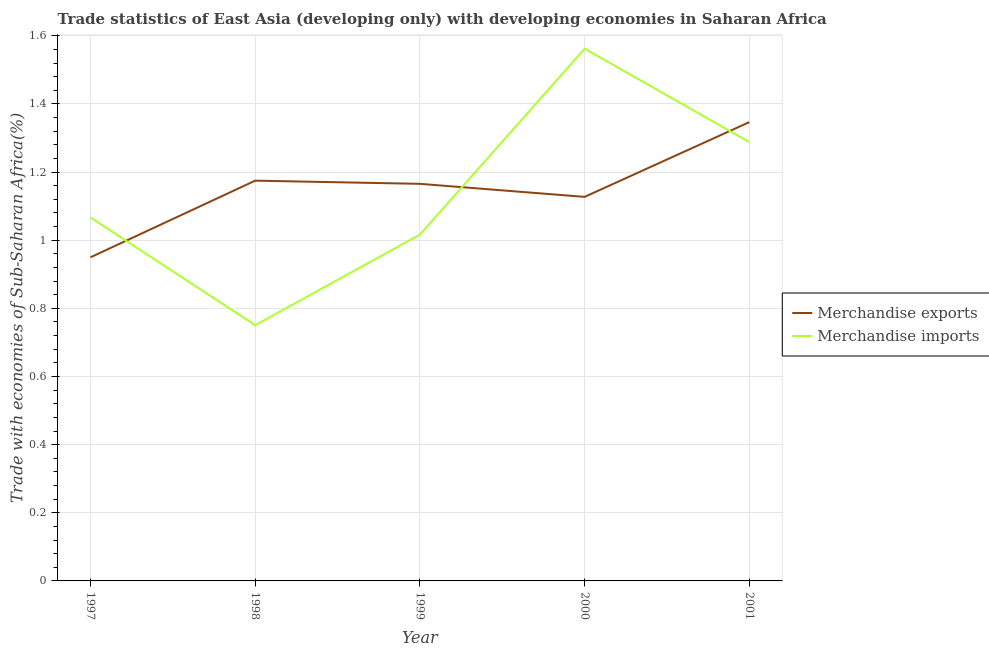How many different coloured lines are there?
Make the answer very short. 2. What is the merchandise exports in 1997?
Your response must be concise. 0.95. Across all years, what is the maximum merchandise imports?
Offer a terse response. 1.56. Across all years, what is the minimum merchandise imports?
Give a very brief answer. 0.75. In which year was the merchandise imports maximum?
Provide a short and direct response. 2000. In which year was the merchandise imports minimum?
Provide a short and direct response. 1998. What is the total merchandise imports in the graph?
Ensure brevity in your answer.  5.68. What is the difference between the merchandise exports in 1997 and that in 1998?
Provide a succinct answer. -0.22. What is the difference between the merchandise imports in 1999 and the merchandise exports in 2000?
Your answer should be very brief. -0.11. What is the average merchandise imports per year?
Ensure brevity in your answer.  1.14. In the year 2000, what is the difference between the merchandise exports and merchandise imports?
Give a very brief answer. -0.43. What is the ratio of the merchandise exports in 1997 to that in 1999?
Make the answer very short. 0.81. Is the merchandise imports in 1998 less than that in 2001?
Provide a short and direct response. Yes. Is the difference between the merchandise imports in 1997 and 2000 greater than the difference between the merchandise exports in 1997 and 2000?
Your answer should be very brief. No. What is the difference between the highest and the second highest merchandise imports?
Keep it short and to the point. 0.27. What is the difference between the highest and the lowest merchandise imports?
Your answer should be compact. 0.81. Is the sum of the merchandise exports in 1997 and 2001 greater than the maximum merchandise imports across all years?
Your answer should be very brief. Yes. Does the merchandise imports monotonically increase over the years?
Offer a terse response. No. Is the merchandise imports strictly greater than the merchandise exports over the years?
Provide a short and direct response. No. How many years are there in the graph?
Provide a short and direct response. 5. Does the graph contain any zero values?
Keep it short and to the point. No. Does the graph contain grids?
Provide a short and direct response. Yes. What is the title of the graph?
Offer a terse response. Trade statistics of East Asia (developing only) with developing economies in Saharan Africa. Does "Overweight" appear as one of the legend labels in the graph?
Your response must be concise. No. What is the label or title of the Y-axis?
Make the answer very short. Trade with economies of Sub-Saharan Africa(%). What is the Trade with economies of Sub-Saharan Africa(%) of Merchandise exports in 1997?
Your answer should be compact. 0.95. What is the Trade with economies of Sub-Saharan Africa(%) in Merchandise imports in 1997?
Keep it short and to the point. 1.07. What is the Trade with economies of Sub-Saharan Africa(%) of Merchandise exports in 1998?
Offer a very short reply. 1.17. What is the Trade with economies of Sub-Saharan Africa(%) of Merchandise imports in 1998?
Offer a very short reply. 0.75. What is the Trade with economies of Sub-Saharan Africa(%) in Merchandise exports in 1999?
Keep it short and to the point. 1.17. What is the Trade with economies of Sub-Saharan Africa(%) of Merchandise imports in 1999?
Provide a short and direct response. 1.02. What is the Trade with economies of Sub-Saharan Africa(%) in Merchandise exports in 2000?
Keep it short and to the point. 1.13. What is the Trade with economies of Sub-Saharan Africa(%) in Merchandise imports in 2000?
Your response must be concise. 1.56. What is the Trade with economies of Sub-Saharan Africa(%) in Merchandise exports in 2001?
Provide a short and direct response. 1.35. What is the Trade with economies of Sub-Saharan Africa(%) of Merchandise imports in 2001?
Your answer should be very brief. 1.29. Across all years, what is the maximum Trade with economies of Sub-Saharan Africa(%) in Merchandise exports?
Your answer should be compact. 1.35. Across all years, what is the maximum Trade with economies of Sub-Saharan Africa(%) of Merchandise imports?
Provide a short and direct response. 1.56. Across all years, what is the minimum Trade with economies of Sub-Saharan Africa(%) of Merchandise exports?
Offer a very short reply. 0.95. Across all years, what is the minimum Trade with economies of Sub-Saharan Africa(%) of Merchandise imports?
Provide a succinct answer. 0.75. What is the total Trade with economies of Sub-Saharan Africa(%) of Merchandise exports in the graph?
Your answer should be very brief. 5.76. What is the total Trade with economies of Sub-Saharan Africa(%) of Merchandise imports in the graph?
Your answer should be very brief. 5.68. What is the difference between the Trade with economies of Sub-Saharan Africa(%) in Merchandise exports in 1997 and that in 1998?
Provide a short and direct response. -0.23. What is the difference between the Trade with economies of Sub-Saharan Africa(%) of Merchandise imports in 1997 and that in 1998?
Your response must be concise. 0.32. What is the difference between the Trade with economies of Sub-Saharan Africa(%) in Merchandise exports in 1997 and that in 1999?
Provide a short and direct response. -0.22. What is the difference between the Trade with economies of Sub-Saharan Africa(%) in Merchandise imports in 1997 and that in 1999?
Keep it short and to the point. 0.05. What is the difference between the Trade with economies of Sub-Saharan Africa(%) of Merchandise exports in 1997 and that in 2000?
Offer a terse response. -0.18. What is the difference between the Trade with economies of Sub-Saharan Africa(%) in Merchandise imports in 1997 and that in 2000?
Offer a very short reply. -0.5. What is the difference between the Trade with economies of Sub-Saharan Africa(%) in Merchandise exports in 1997 and that in 2001?
Ensure brevity in your answer.  -0.4. What is the difference between the Trade with economies of Sub-Saharan Africa(%) of Merchandise imports in 1997 and that in 2001?
Your response must be concise. -0.22. What is the difference between the Trade with economies of Sub-Saharan Africa(%) of Merchandise exports in 1998 and that in 1999?
Offer a very short reply. 0.01. What is the difference between the Trade with economies of Sub-Saharan Africa(%) in Merchandise imports in 1998 and that in 1999?
Offer a very short reply. -0.27. What is the difference between the Trade with economies of Sub-Saharan Africa(%) in Merchandise exports in 1998 and that in 2000?
Provide a short and direct response. 0.05. What is the difference between the Trade with economies of Sub-Saharan Africa(%) in Merchandise imports in 1998 and that in 2000?
Give a very brief answer. -0.81. What is the difference between the Trade with economies of Sub-Saharan Africa(%) of Merchandise exports in 1998 and that in 2001?
Provide a succinct answer. -0.17. What is the difference between the Trade with economies of Sub-Saharan Africa(%) in Merchandise imports in 1998 and that in 2001?
Provide a short and direct response. -0.54. What is the difference between the Trade with economies of Sub-Saharan Africa(%) of Merchandise exports in 1999 and that in 2000?
Give a very brief answer. 0.04. What is the difference between the Trade with economies of Sub-Saharan Africa(%) in Merchandise imports in 1999 and that in 2000?
Give a very brief answer. -0.55. What is the difference between the Trade with economies of Sub-Saharan Africa(%) of Merchandise exports in 1999 and that in 2001?
Provide a short and direct response. -0.18. What is the difference between the Trade with economies of Sub-Saharan Africa(%) of Merchandise imports in 1999 and that in 2001?
Your response must be concise. -0.27. What is the difference between the Trade with economies of Sub-Saharan Africa(%) of Merchandise exports in 2000 and that in 2001?
Provide a succinct answer. -0.22. What is the difference between the Trade with economies of Sub-Saharan Africa(%) of Merchandise imports in 2000 and that in 2001?
Provide a short and direct response. 0.27. What is the difference between the Trade with economies of Sub-Saharan Africa(%) in Merchandise exports in 1997 and the Trade with economies of Sub-Saharan Africa(%) in Merchandise imports in 1998?
Keep it short and to the point. 0.2. What is the difference between the Trade with economies of Sub-Saharan Africa(%) in Merchandise exports in 1997 and the Trade with economies of Sub-Saharan Africa(%) in Merchandise imports in 1999?
Make the answer very short. -0.07. What is the difference between the Trade with economies of Sub-Saharan Africa(%) in Merchandise exports in 1997 and the Trade with economies of Sub-Saharan Africa(%) in Merchandise imports in 2000?
Provide a succinct answer. -0.61. What is the difference between the Trade with economies of Sub-Saharan Africa(%) of Merchandise exports in 1997 and the Trade with economies of Sub-Saharan Africa(%) of Merchandise imports in 2001?
Provide a succinct answer. -0.34. What is the difference between the Trade with economies of Sub-Saharan Africa(%) of Merchandise exports in 1998 and the Trade with economies of Sub-Saharan Africa(%) of Merchandise imports in 1999?
Ensure brevity in your answer.  0.16. What is the difference between the Trade with economies of Sub-Saharan Africa(%) of Merchandise exports in 1998 and the Trade with economies of Sub-Saharan Africa(%) of Merchandise imports in 2000?
Make the answer very short. -0.39. What is the difference between the Trade with economies of Sub-Saharan Africa(%) in Merchandise exports in 1998 and the Trade with economies of Sub-Saharan Africa(%) in Merchandise imports in 2001?
Make the answer very short. -0.11. What is the difference between the Trade with economies of Sub-Saharan Africa(%) in Merchandise exports in 1999 and the Trade with economies of Sub-Saharan Africa(%) in Merchandise imports in 2000?
Offer a terse response. -0.4. What is the difference between the Trade with economies of Sub-Saharan Africa(%) in Merchandise exports in 1999 and the Trade with economies of Sub-Saharan Africa(%) in Merchandise imports in 2001?
Offer a very short reply. -0.12. What is the difference between the Trade with economies of Sub-Saharan Africa(%) in Merchandise exports in 2000 and the Trade with economies of Sub-Saharan Africa(%) in Merchandise imports in 2001?
Your answer should be compact. -0.16. What is the average Trade with economies of Sub-Saharan Africa(%) in Merchandise exports per year?
Your response must be concise. 1.15. What is the average Trade with economies of Sub-Saharan Africa(%) in Merchandise imports per year?
Keep it short and to the point. 1.14. In the year 1997, what is the difference between the Trade with economies of Sub-Saharan Africa(%) in Merchandise exports and Trade with economies of Sub-Saharan Africa(%) in Merchandise imports?
Make the answer very short. -0.12. In the year 1998, what is the difference between the Trade with economies of Sub-Saharan Africa(%) in Merchandise exports and Trade with economies of Sub-Saharan Africa(%) in Merchandise imports?
Give a very brief answer. 0.42. In the year 1999, what is the difference between the Trade with economies of Sub-Saharan Africa(%) in Merchandise exports and Trade with economies of Sub-Saharan Africa(%) in Merchandise imports?
Your answer should be very brief. 0.15. In the year 2000, what is the difference between the Trade with economies of Sub-Saharan Africa(%) of Merchandise exports and Trade with economies of Sub-Saharan Africa(%) of Merchandise imports?
Your answer should be very brief. -0.43. In the year 2001, what is the difference between the Trade with economies of Sub-Saharan Africa(%) in Merchandise exports and Trade with economies of Sub-Saharan Africa(%) in Merchandise imports?
Provide a succinct answer. 0.06. What is the ratio of the Trade with economies of Sub-Saharan Africa(%) in Merchandise exports in 1997 to that in 1998?
Provide a short and direct response. 0.81. What is the ratio of the Trade with economies of Sub-Saharan Africa(%) in Merchandise imports in 1997 to that in 1998?
Give a very brief answer. 1.42. What is the ratio of the Trade with economies of Sub-Saharan Africa(%) of Merchandise exports in 1997 to that in 1999?
Your answer should be compact. 0.81. What is the ratio of the Trade with economies of Sub-Saharan Africa(%) of Merchandise imports in 1997 to that in 1999?
Your response must be concise. 1.05. What is the ratio of the Trade with economies of Sub-Saharan Africa(%) in Merchandise exports in 1997 to that in 2000?
Ensure brevity in your answer.  0.84. What is the ratio of the Trade with economies of Sub-Saharan Africa(%) in Merchandise imports in 1997 to that in 2000?
Offer a very short reply. 0.68. What is the ratio of the Trade with economies of Sub-Saharan Africa(%) of Merchandise exports in 1997 to that in 2001?
Your answer should be compact. 0.71. What is the ratio of the Trade with economies of Sub-Saharan Africa(%) in Merchandise imports in 1997 to that in 2001?
Your response must be concise. 0.83. What is the ratio of the Trade with economies of Sub-Saharan Africa(%) of Merchandise exports in 1998 to that in 1999?
Your answer should be very brief. 1.01. What is the ratio of the Trade with economies of Sub-Saharan Africa(%) in Merchandise imports in 1998 to that in 1999?
Your response must be concise. 0.74. What is the ratio of the Trade with economies of Sub-Saharan Africa(%) in Merchandise exports in 1998 to that in 2000?
Give a very brief answer. 1.04. What is the ratio of the Trade with economies of Sub-Saharan Africa(%) of Merchandise imports in 1998 to that in 2000?
Your response must be concise. 0.48. What is the ratio of the Trade with economies of Sub-Saharan Africa(%) in Merchandise exports in 1998 to that in 2001?
Ensure brevity in your answer.  0.87. What is the ratio of the Trade with economies of Sub-Saharan Africa(%) of Merchandise imports in 1998 to that in 2001?
Offer a very short reply. 0.58. What is the ratio of the Trade with economies of Sub-Saharan Africa(%) of Merchandise exports in 1999 to that in 2000?
Your answer should be very brief. 1.03. What is the ratio of the Trade with economies of Sub-Saharan Africa(%) of Merchandise imports in 1999 to that in 2000?
Give a very brief answer. 0.65. What is the ratio of the Trade with economies of Sub-Saharan Africa(%) of Merchandise exports in 1999 to that in 2001?
Offer a very short reply. 0.87. What is the ratio of the Trade with economies of Sub-Saharan Africa(%) in Merchandise imports in 1999 to that in 2001?
Offer a terse response. 0.79. What is the ratio of the Trade with economies of Sub-Saharan Africa(%) of Merchandise exports in 2000 to that in 2001?
Ensure brevity in your answer.  0.84. What is the ratio of the Trade with economies of Sub-Saharan Africa(%) in Merchandise imports in 2000 to that in 2001?
Provide a succinct answer. 1.21. What is the difference between the highest and the second highest Trade with economies of Sub-Saharan Africa(%) in Merchandise exports?
Your response must be concise. 0.17. What is the difference between the highest and the second highest Trade with economies of Sub-Saharan Africa(%) in Merchandise imports?
Offer a very short reply. 0.27. What is the difference between the highest and the lowest Trade with economies of Sub-Saharan Africa(%) of Merchandise exports?
Give a very brief answer. 0.4. What is the difference between the highest and the lowest Trade with economies of Sub-Saharan Africa(%) of Merchandise imports?
Your answer should be compact. 0.81. 